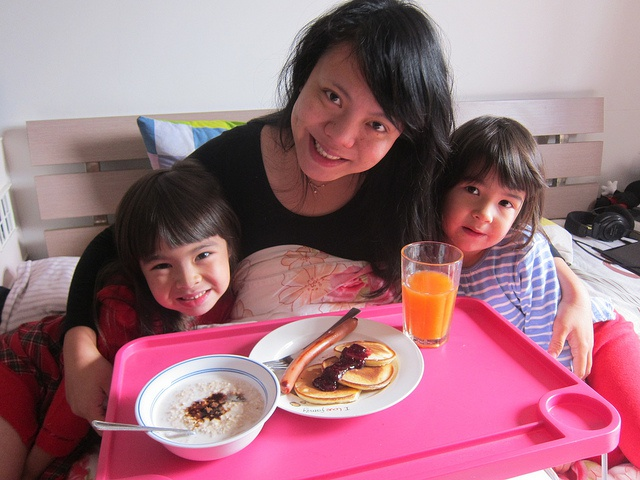Describe the objects in this image and their specific colors. I can see people in darkgray, black, brown, and maroon tones, people in darkgray, black, maroon, brown, and lightpink tones, people in darkgray, black, gray, brown, and violet tones, bowl in darkgray, lightgray, pink, and violet tones, and bed in darkgray, lightgray, and gray tones in this image. 